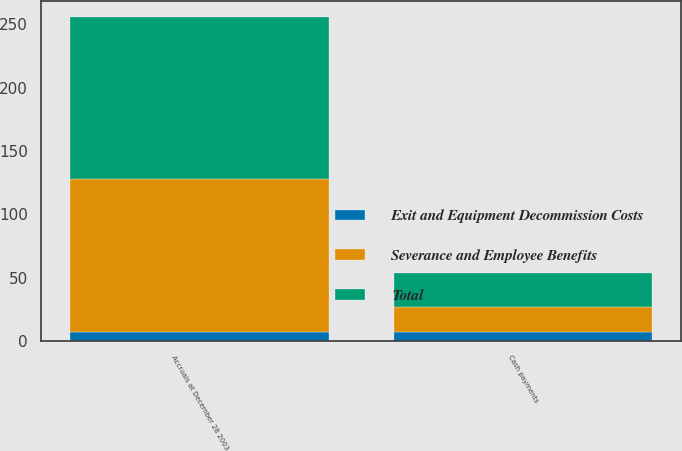Convert chart. <chart><loc_0><loc_0><loc_500><loc_500><stacked_bar_chart><ecel><fcel>Accruals at December 28 2003<fcel>Cash payments<nl><fcel>Exit and Equipment Decommission Costs<fcel>7<fcel>7<nl><fcel>Severance and Employee Benefits<fcel>121<fcel>20<nl><fcel>Total<fcel>128<fcel>27<nl></chart> 